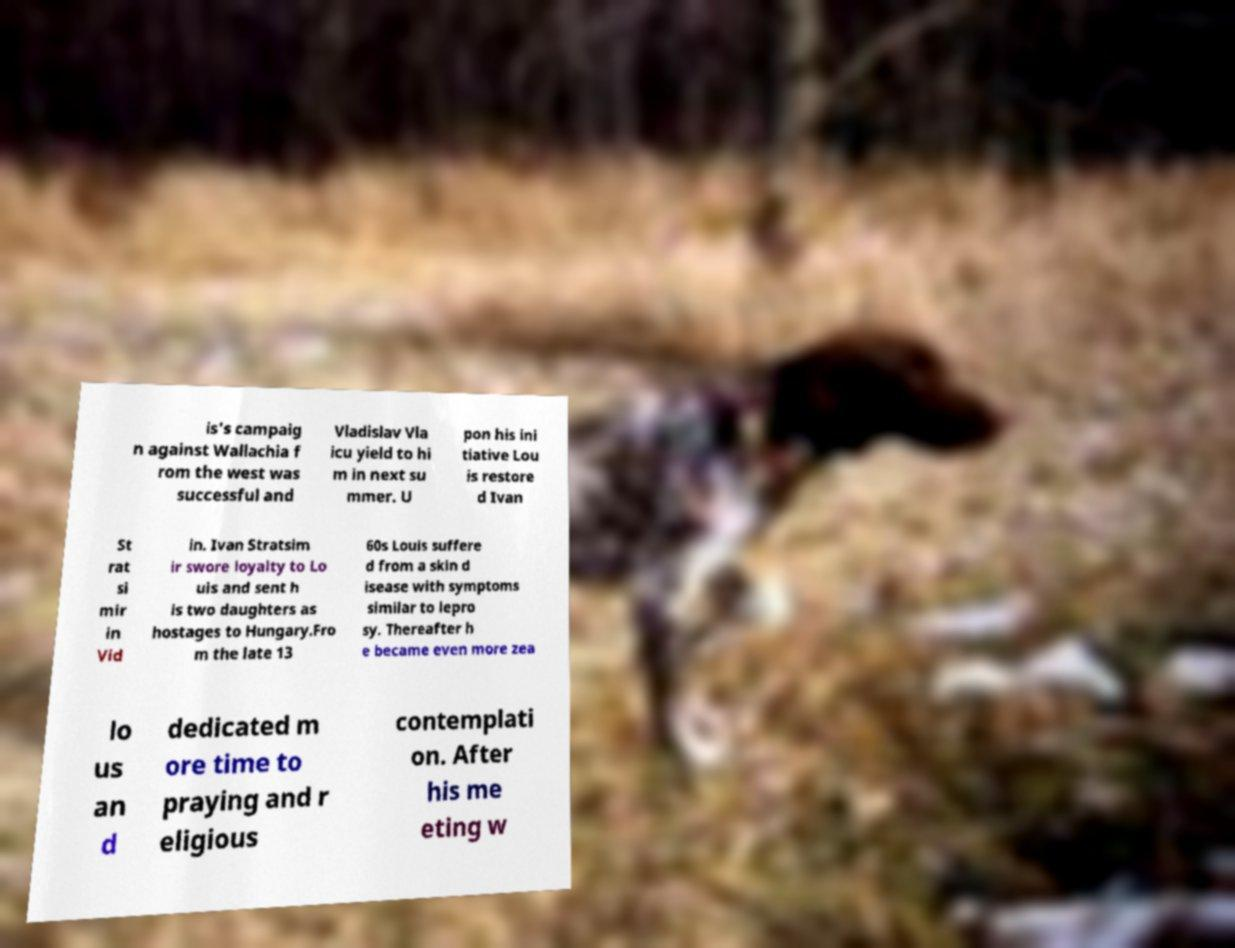Could you extract and type out the text from this image? is's campaig n against Wallachia f rom the west was successful and Vladislav Vla icu yield to hi m in next su mmer. U pon his ini tiative Lou is restore d Ivan St rat si mir in Vid in. Ivan Stratsim ir swore loyalty to Lo uis and sent h is two daughters as hostages to Hungary.Fro m the late 13 60s Louis suffere d from a skin d isease with symptoms similar to lepro sy. Thereafter h e became even more zea lo us an d dedicated m ore time to praying and r eligious contemplati on. After his me eting w 